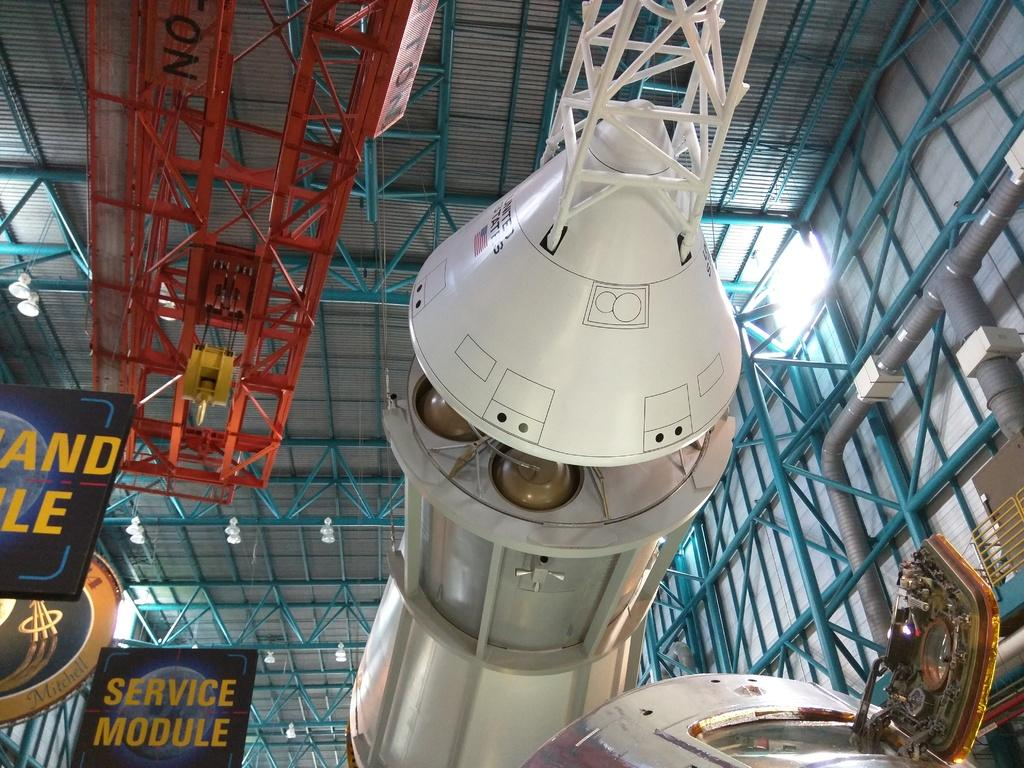<image>
Create a compact narrative representing the image presented. A white space aircraft with United States and a flag on the cone hangs on display. 